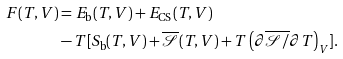Convert formula to latex. <formula><loc_0><loc_0><loc_500><loc_500>F ( T , V ) & = E _ { \text {b} } ( T , V ) + E _ { \text {CS} } ( T , V ) \\ & - T [ S _ { \text {b} } ( T , V ) + \overline { \mathcal { S } } ( T , V ) + T \left ( \partial \overline { \mathcal { S } / } \partial T \right ) _ { V } ] .</formula> 